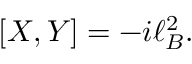Convert formula to latex. <formula><loc_0><loc_0><loc_500><loc_500>[ X , Y ] = - i \ell _ { B } ^ { 2 } .</formula> 